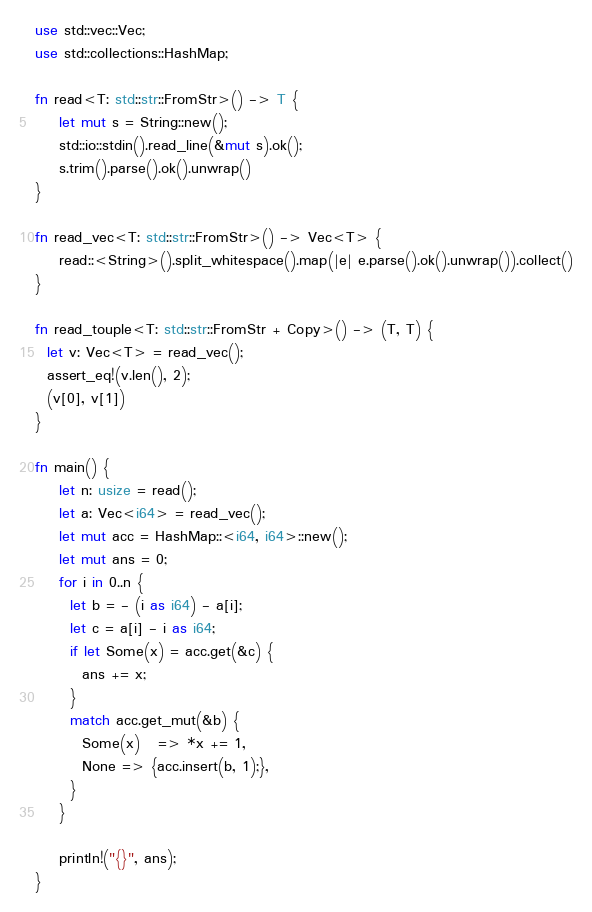Convert code to text. <code><loc_0><loc_0><loc_500><loc_500><_Rust_>use std::vec::Vec;
use std::collections::HashMap;

fn read<T: std::str::FromStr>() -> T {
    let mut s = String::new();
    std::io::stdin().read_line(&mut s).ok();
    s.trim().parse().ok().unwrap()
}

fn read_vec<T: std::str::FromStr>() -> Vec<T> {
    read::<String>().split_whitespace().map(|e| e.parse().ok().unwrap()).collect()
}

fn read_touple<T: std::str::FromStr + Copy>() -> (T, T) {
  let v: Vec<T> = read_vec();
  assert_eq!(v.len(), 2);
  (v[0], v[1])
}

fn main() {
    let n: usize = read();
    let a: Vec<i64> = read_vec();
    let mut acc = HashMap::<i64, i64>::new();
    let mut ans = 0;
    for i in 0..n {
      let b = - (i as i64) - a[i];
      let c = a[i] - i as i64;
      if let Some(x) = acc.get(&c) {
        ans += x;
      }
      match acc.get_mut(&b) {
        Some(x)   => *x += 1,
        None => {acc.insert(b, 1);},
      }
    }

    println!("{}", ans);
}
</code> 